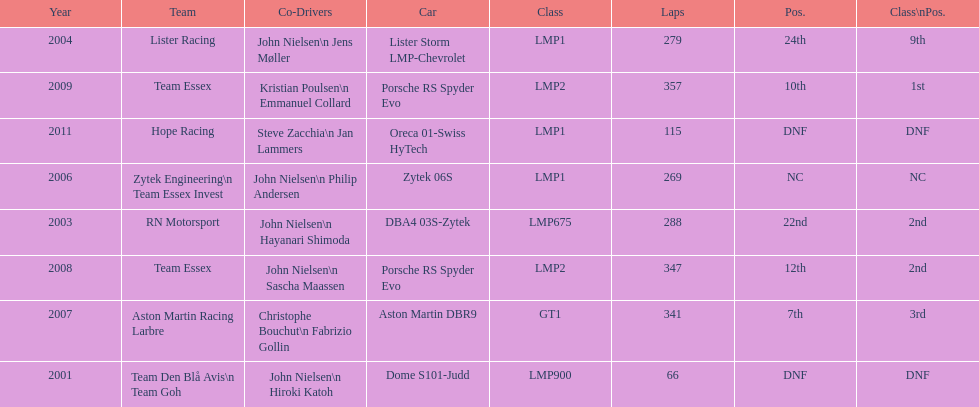Who was casper elgaard's co-driver the most often for the 24 hours of le mans? John Nielsen. 